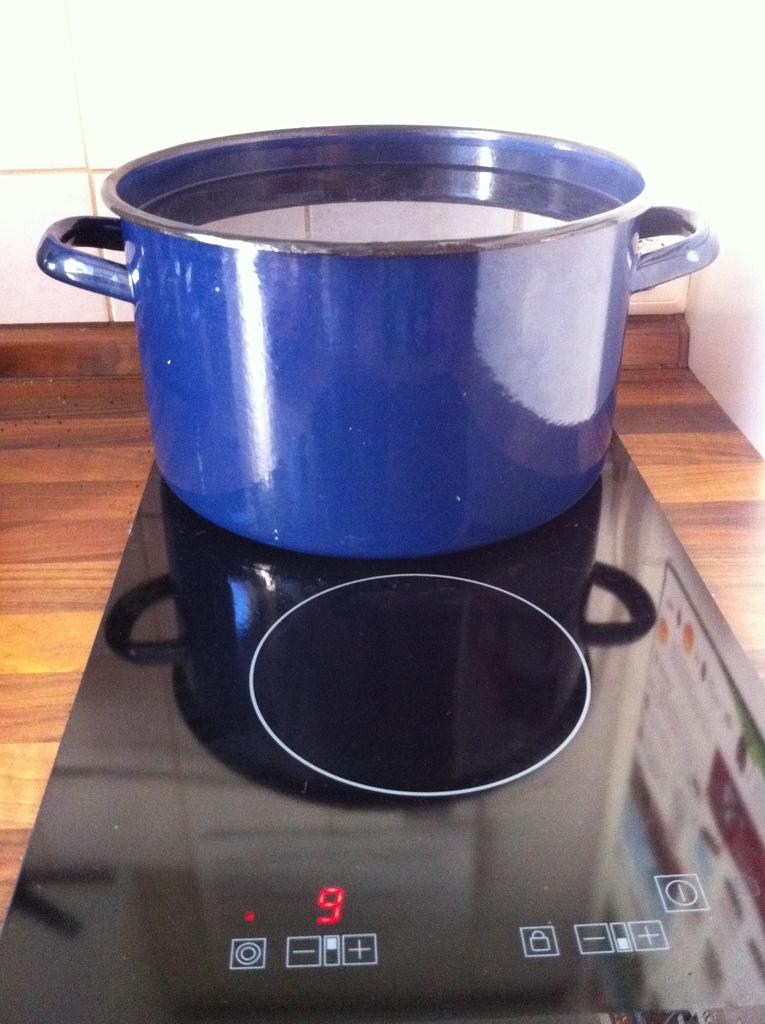<image>
Create a compact narrative representing the image presented. A pot of water on a stove with the temp level turned to 9. 